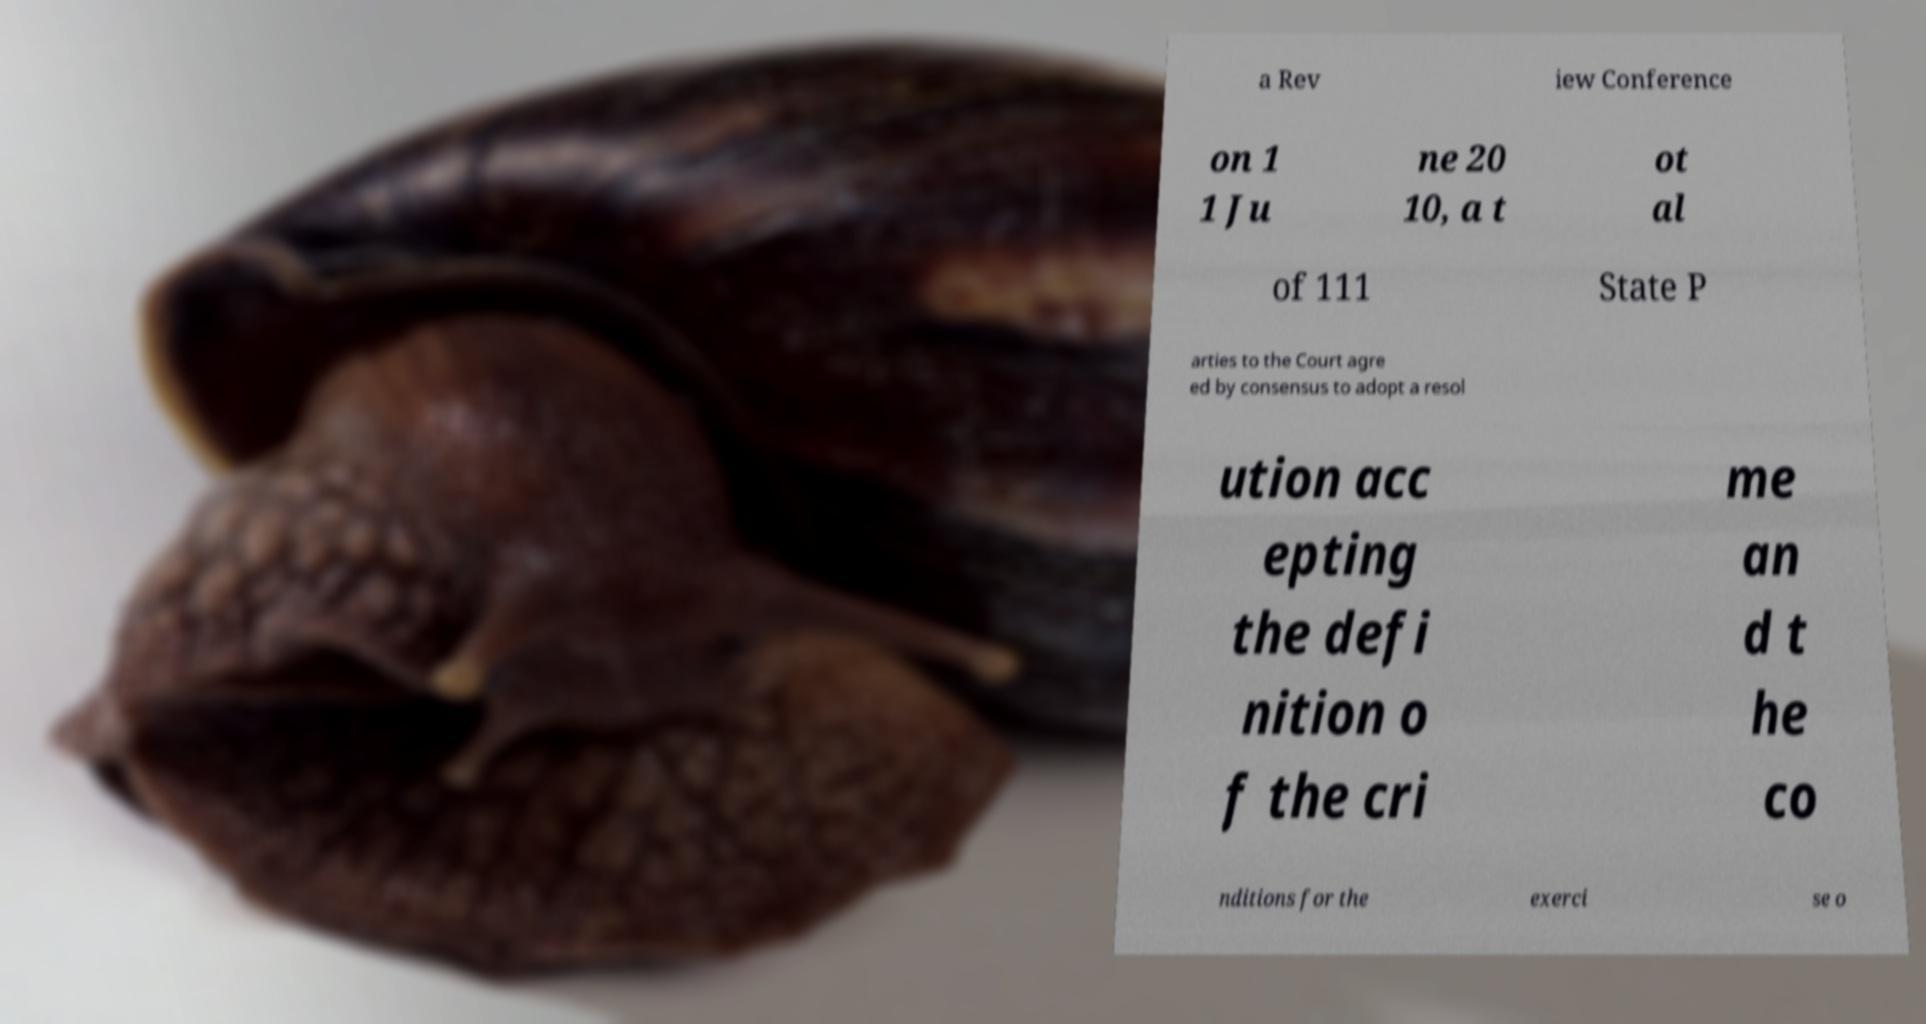Please read and relay the text visible in this image. What does it say? a Rev iew Conference on 1 1 Ju ne 20 10, a t ot al of 111 State P arties to the Court agre ed by consensus to adopt a resol ution acc epting the defi nition o f the cri me an d t he co nditions for the exerci se o 